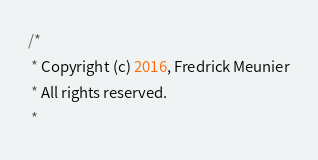<code> <loc_0><loc_0><loc_500><loc_500><_Java_>/*
 * Copyright (c) 2016, Fredrick Meunier
 * All rights reserved.
 *</code> 